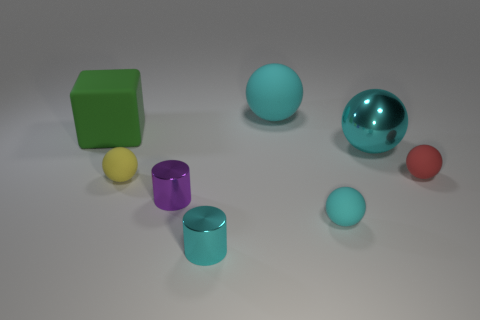Add 2 big green cubes. How many objects exist? 10 Subtract all red matte balls. How many balls are left? 4 Subtract 0 gray spheres. How many objects are left? 8 Subtract all cylinders. How many objects are left? 6 Subtract 1 blocks. How many blocks are left? 0 Subtract all purple spheres. Subtract all gray cylinders. How many spheres are left? 5 Subtract all blue cubes. How many gray spheres are left? 0 Subtract all large cyan objects. Subtract all small cyan things. How many objects are left? 4 Add 5 tiny red balls. How many tiny red balls are left? 6 Add 2 cyan balls. How many cyan balls exist? 5 